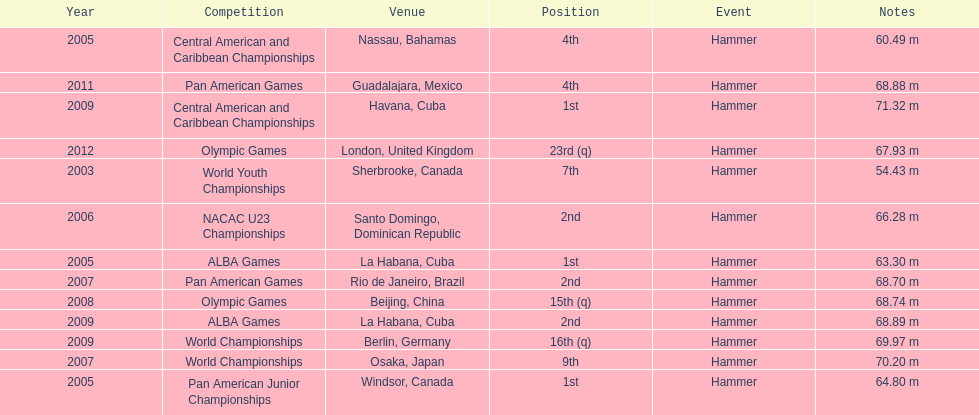Does arasay thondike have more/less than 4 1st place tournament finishes? Less. 